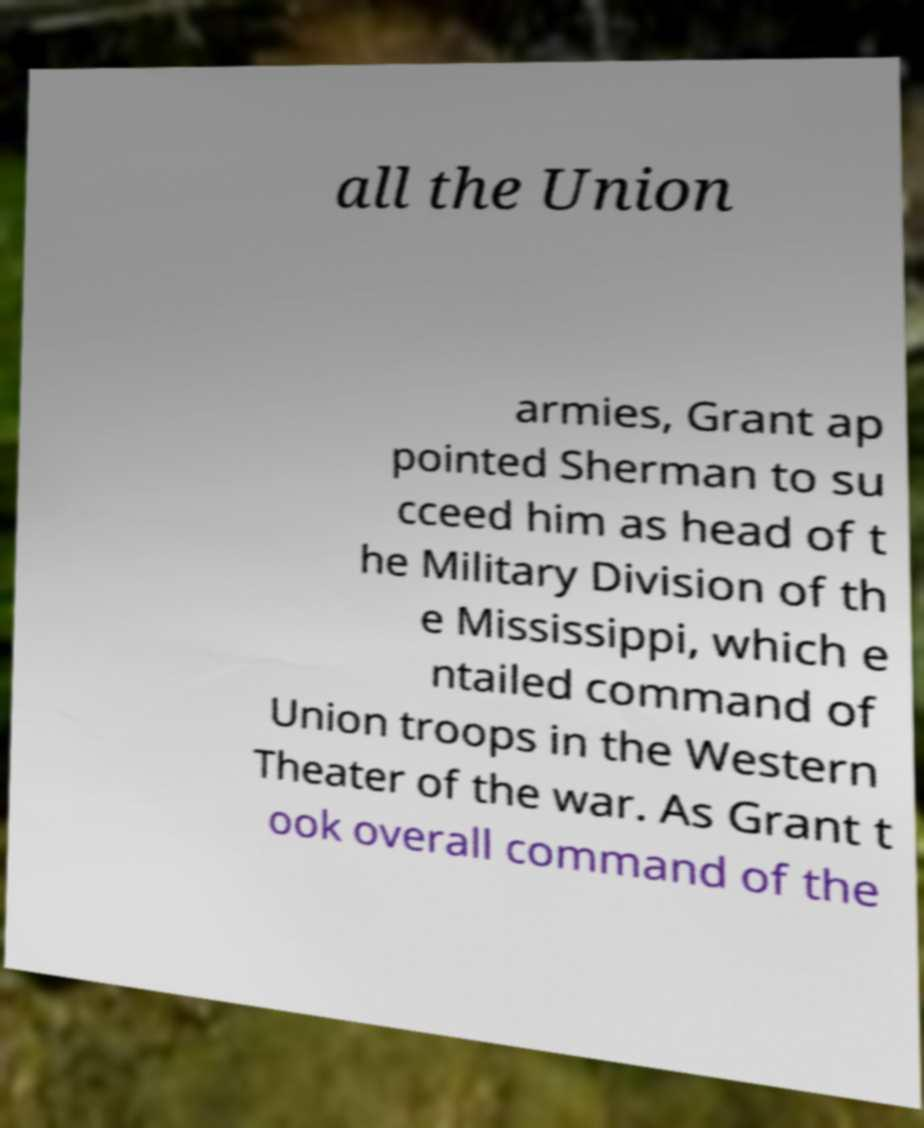Could you assist in decoding the text presented in this image and type it out clearly? all the Union armies, Grant ap pointed Sherman to su cceed him as head of t he Military Division of th e Mississippi, which e ntailed command of Union troops in the Western Theater of the war. As Grant t ook overall command of the 